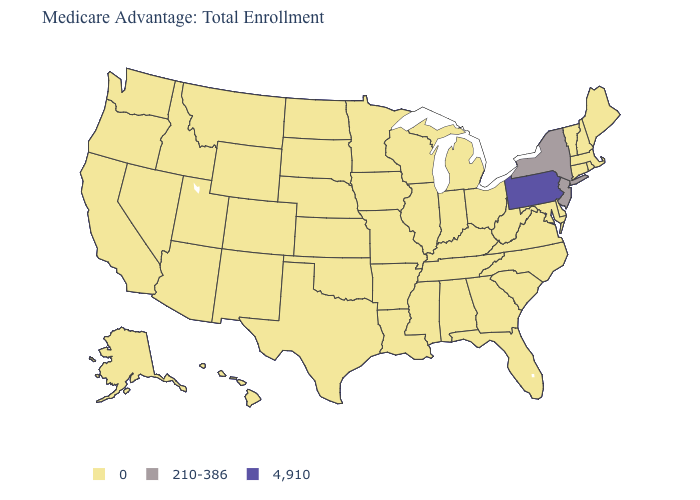What is the value of Mississippi?
Be succinct. 0. Name the states that have a value in the range 4,910?
Quick response, please. Pennsylvania. Name the states that have a value in the range 0?
Quick response, please. Alaska, Alabama, Arkansas, Arizona, California, Colorado, Connecticut, Delaware, Florida, Georgia, Hawaii, Iowa, Idaho, Illinois, Indiana, Kansas, Kentucky, Louisiana, Massachusetts, Maryland, Maine, Michigan, Minnesota, Missouri, Mississippi, Montana, North Carolina, North Dakota, Nebraska, New Hampshire, New Mexico, Nevada, Ohio, Oklahoma, Oregon, Rhode Island, South Carolina, South Dakota, Tennessee, Texas, Utah, Virginia, Vermont, Washington, Wisconsin, West Virginia, Wyoming. Among the states that border Oklahoma , which have the lowest value?
Quick response, please. Arkansas, Colorado, Kansas, Missouri, New Mexico, Texas. Does Missouri have a lower value than Pennsylvania?
Short answer required. Yes. What is the lowest value in the USA?
Write a very short answer. 0. Name the states that have a value in the range 4,910?
Keep it brief. Pennsylvania. Does the map have missing data?
Be succinct. No. Name the states that have a value in the range 4,910?
Keep it brief. Pennsylvania. Name the states that have a value in the range 4,910?
Be succinct. Pennsylvania. What is the highest value in the MidWest ?
Answer briefly. 0. What is the lowest value in the USA?
Write a very short answer. 0. What is the lowest value in states that border Vermont?
Quick response, please. 0. Name the states that have a value in the range 210-386?
Keep it brief. New Jersey, New York. 